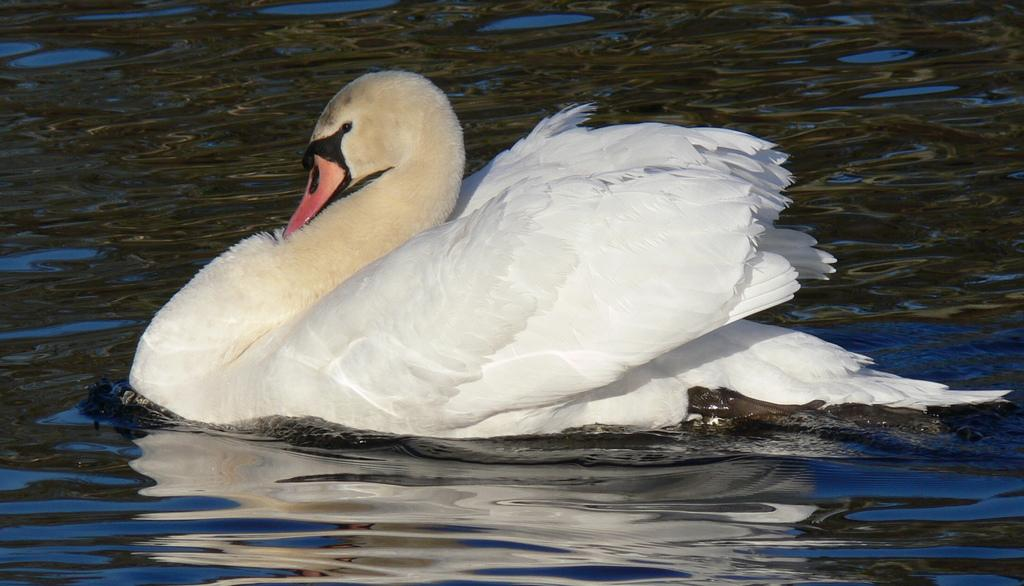What is the primary element in the image? There is water in the image. What animal can be seen in the water? A swan is swimming in the water. What type of sweater is the swan wearing in the image? There is no sweater present in the image; the swan is swimming in the water without any clothing. 